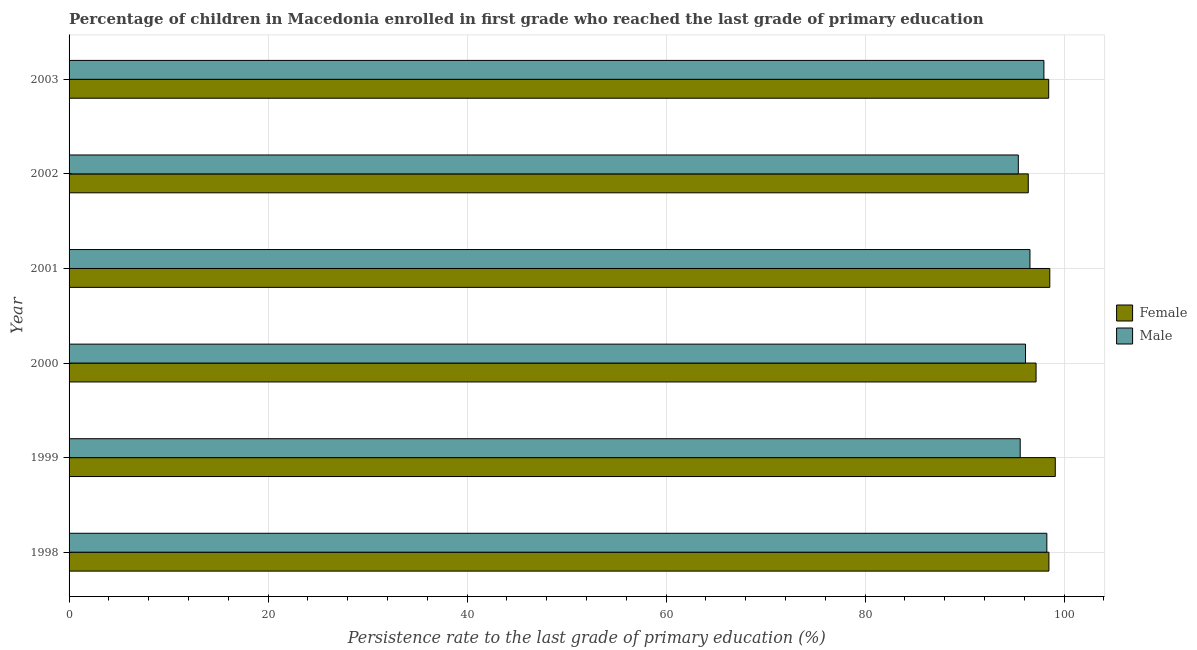Are the number of bars on each tick of the Y-axis equal?
Ensure brevity in your answer.  Yes. How many bars are there on the 3rd tick from the top?
Give a very brief answer. 2. How many bars are there on the 1st tick from the bottom?
Keep it short and to the point. 2. What is the persistence rate of female students in 2001?
Offer a terse response. 98.55. Across all years, what is the maximum persistence rate of male students?
Keep it short and to the point. 98.26. Across all years, what is the minimum persistence rate of male students?
Offer a terse response. 95.39. In which year was the persistence rate of female students maximum?
Your answer should be very brief. 1999. What is the total persistence rate of female students in the graph?
Ensure brevity in your answer.  588.14. What is the difference between the persistence rate of female students in 2000 and that in 2003?
Keep it short and to the point. -1.27. What is the difference between the persistence rate of male students in 1998 and the persistence rate of female students in 2001?
Ensure brevity in your answer.  -0.3. What is the average persistence rate of male students per year?
Make the answer very short. 96.64. In the year 2003, what is the difference between the persistence rate of female students and persistence rate of male students?
Offer a terse response. 0.48. In how many years, is the persistence rate of male students greater than 84 %?
Provide a succinct answer. 6. What is the ratio of the persistence rate of female students in 1998 to that in 2000?
Give a very brief answer. 1.01. Is the persistence rate of male students in 1999 less than that in 2002?
Offer a terse response. No. What is the difference between the highest and the second highest persistence rate of male students?
Keep it short and to the point. 0.29. What is the difference between the highest and the lowest persistence rate of male students?
Ensure brevity in your answer.  2.87. What does the 1st bar from the top in 2000 represents?
Your answer should be very brief. Male. What does the 2nd bar from the bottom in 1998 represents?
Your response must be concise. Male. Are all the bars in the graph horizontal?
Give a very brief answer. Yes. How many years are there in the graph?
Ensure brevity in your answer.  6. Does the graph contain grids?
Make the answer very short. Yes. How many legend labels are there?
Your answer should be very brief. 2. How are the legend labels stacked?
Keep it short and to the point. Vertical. What is the title of the graph?
Offer a terse response. Percentage of children in Macedonia enrolled in first grade who reached the last grade of primary education. What is the label or title of the X-axis?
Provide a short and direct response. Persistence rate to the last grade of primary education (%). What is the label or title of the Y-axis?
Provide a short and direct response. Year. What is the Persistence rate to the last grade of primary education (%) of Female in 1998?
Ensure brevity in your answer.  98.47. What is the Persistence rate to the last grade of primary education (%) in Male in 1998?
Keep it short and to the point. 98.26. What is the Persistence rate to the last grade of primary education (%) in Female in 1999?
Ensure brevity in your answer.  99.1. What is the Persistence rate to the last grade of primary education (%) of Male in 1999?
Offer a terse response. 95.58. What is the Persistence rate to the last grade of primary education (%) of Female in 2000?
Make the answer very short. 97.18. What is the Persistence rate to the last grade of primary education (%) of Male in 2000?
Offer a terse response. 96.11. What is the Persistence rate to the last grade of primary education (%) in Female in 2001?
Make the answer very short. 98.55. What is the Persistence rate to the last grade of primary education (%) of Male in 2001?
Ensure brevity in your answer.  96.56. What is the Persistence rate to the last grade of primary education (%) in Female in 2002?
Ensure brevity in your answer.  96.39. What is the Persistence rate to the last grade of primary education (%) of Male in 2002?
Offer a terse response. 95.39. What is the Persistence rate to the last grade of primary education (%) in Female in 2003?
Offer a terse response. 98.44. What is the Persistence rate to the last grade of primary education (%) in Male in 2003?
Ensure brevity in your answer.  97.96. Across all years, what is the maximum Persistence rate to the last grade of primary education (%) of Female?
Keep it short and to the point. 99.1. Across all years, what is the maximum Persistence rate to the last grade of primary education (%) of Male?
Your answer should be very brief. 98.26. Across all years, what is the minimum Persistence rate to the last grade of primary education (%) of Female?
Make the answer very short. 96.39. Across all years, what is the minimum Persistence rate to the last grade of primary education (%) of Male?
Offer a very short reply. 95.39. What is the total Persistence rate to the last grade of primary education (%) of Female in the graph?
Provide a succinct answer. 588.14. What is the total Persistence rate to the last grade of primary education (%) of Male in the graph?
Give a very brief answer. 579.87. What is the difference between the Persistence rate to the last grade of primary education (%) in Female in 1998 and that in 1999?
Keep it short and to the point. -0.64. What is the difference between the Persistence rate to the last grade of primary education (%) of Male in 1998 and that in 1999?
Keep it short and to the point. 2.68. What is the difference between the Persistence rate to the last grade of primary education (%) in Female in 1998 and that in 2000?
Ensure brevity in your answer.  1.29. What is the difference between the Persistence rate to the last grade of primary education (%) in Male in 1998 and that in 2000?
Ensure brevity in your answer.  2.14. What is the difference between the Persistence rate to the last grade of primary education (%) of Female in 1998 and that in 2001?
Your answer should be compact. -0.09. What is the difference between the Persistence rate to the last grade of primary education (%) in Male in 1998 and that in 2001?
Provide a short and direct response. 1.7. What is the difference between the Persistence rate to the last grade of primary education (%) in Female in 1998 and that in 2002?
Ensure brevity in your answer.  2.08. What is the difference between the Persistence rate to the last grade of primary education (%) of Male in 1998 and that in 2002?
Your answer should be compact. 2.87. What is the difference between the Persistence rate to the last grade of primary education (%) of Female in 1998 and that in 2003?
Your response must be concise. 0.02. What is the difference between the Persistence rate to the last grade of primary education (%) in Male in 1998 and that in 2003?
Your response must be concise. 0.3. What is the difference between the Persistence rate to the last grade of primary education (%) in Female in 1999 and that in 2000?
Give a very brief answer. 1.93. What is the difference between the Persistence rate to the last grade of primary education (%) of Male in 1999 and that in 2000?
Provide a short and direct response. -0.53. What is the difference between the Persistence rate to the last grade of primary education (%) of Female in 1999 and that in 2001?
Offer a very short reply. 0.55. What is the difference between the Persistence rate to the last grade of primary education (%) of Male in 1999 and that in 2001?
Ensure brevity in your answer.  -0.98. What is the difference between the Persistence rate to the last grade of primary education (%) in Female in 1999 and that in 2002?
Give a very brief answer. 2.71. What is the difference between the Persistence rate to the last grade of primary education (%) of Male in 1999 and that in 2002?
Your response must be concise. 0.19. What is the difference between the Persistence rate to the last grade of primary education (%) in Female in 1999 and that in 2003?
Provide a succinct answer. 0.66. What is the difference between the Persistence rate to the last grade of primary education (%) of Male in 1999 and that in 2003?
Give a very brief answer. -2.38. What is the difference between the Persistence rate to the last grade of primary education (%) in Female in 2000 and that in 2001?
Offer a terse response. -1.38. What is the difference between the Persistence rate to the last grade of primary education (%) of Male in 2000 and that in 2001?
Your answer should be very brief. -0.45. What is the difference between the Persistence rate to the last grade of primary education (%) in Female in 2000 and that in 2002?
Keep it short and to the point. 0.79. What is the difference between the Persistence rate to the last grade of primary education (%) of Male in 2000 and that in 2002?
Your response must be concise. 0.72. What is the difference between the Persistence rate to the last grade of primary education (%) in Female in 2000 and that in 2003?
Make the answer very short. -1.27. What is the difference between the Persistence rate to the last grade of primary education (%) of Male in 2000 and that in 2003?
Make the answer very short. -1.85. What is the difference between the Persistence rate to the last grade of primary education (%) of Female in 2001 and that in 2002?
Offer a terse response. 2.16. What is the difference between the Persistence rate to the last grade of primary education (%) of Male in 2001 and that in 2002?
Your response must be concise. 1.17. What is the difference between the Persistence rate to the last grade of primary education (%) of Female in 2001 and that in 2003?
Keep it short and to the point. 0.11. What is the difference between the Persistence rate to the last grade of primary education (%) in Male in 2001 and that in 2003?
Your answer should be compact. -1.4. What is the difference between the Persistence rate to the last grade of primary education (%) in Female in 2002 and that in 2003?
Offer a very short reply. -2.05. What is the difference between the Persistence rate to the last grade of primary education (%) in Male in 2002 and that in 2003?
Your answer should be compact. -2.57. What is the difference between the Persistence rate to the last grade of primary education (%) of Female in 1998 and the Persistence rate to the last grade of primary education (%) of Male in 1999?
Make the answer very short. 2.89. What is the difference between the Persistence rate to the last grade of primary education (%) in Female in 1998 and the Persistence rate to the last grade of primary education (%) in Male in 2000?
Provide a succinct answer. 2.35. What is the difference between the Persistence rate to the last grade of primary education (%) of Female in 1998 and the Persistence rate to the last grade of primary education (%) of Male in 2001?
Keep it short and to the point. 1.9. What is the difference between the Persistence rate to the last grade of primary education (%) in Female in 1998 and the Persistence rate to the last grade of primary education (%) in Male in 2002?
Make the answer very short. 3.08. What is the difference between the Persistence rate to the last grade of primary education (%) of Female in 1998 and the Persistence rate to the last grade of primary education (%) of Male in 2003?
Provide a succinct answer. 0.5. What is the difference between the Persistence rate to the last grade of primary education (%) of Female in 1999 and the Persistence rate to the last grade of primary education (%) of Male in 2000?
Make the answer very short. 2.99. What is the difference between the Persistence rate to the last grade of primary education (%) of Female in 1999 and the Persistence rate to the last grade of primary education (%) of Male in 2001?
Offer a very short reply. 2.54. What is the difference between the Persistence rate to the last grade of primary education (%) of Female in 1999 and the Persistence rate to the last grade of primary education (%) of Male in 2002?
Ensure brevity in your answer.  3.71. What is the difference between the Persistence rate to the last grade of primary education (%) of Female in 1999 and the Persistence rate to the last grade of primary education (%) of Male in 2003?
Keep it short and to the point. 1.14. What is the difference between the Persistence rate to the last grade of primary education (%) in Female in 2000 and the Persistence rate to the last grade of primary education (%) in Male in 2001?
Offer a very short reply. 0.61. What is the difference between the Persistence rate to the last grade of primary education (%) in Female in 2000 and the Persistence rate to the last grade of primary education (%) in Male in 2002?
Provide a short and direct response. 1.78. What is the difference between the Persistence rate to the last grade of primary education (%) of Female in 2000 and the Persistence rate to the last grade of primary education (%) of Male in 2003?
Ensure brevity in your answer.  -0.79. What is the difference between the Persistence rate to the last grade of primary education (%) in Female in 2001 and the Persistence rate to the last grade of primary education (%) in Male in 2002?
Provide a succinct answer. 3.16. What is the difference between the Persistence rate to the last grade of primary education (%) of Female in 2001 and the Persistence rate to the last grade of primary education (%) of Male in 2003?
Your response must be concise. 0.59. What is the difference between the Persistence rate to the last grade of primary education (%) in Female in 2002 and the Persistence rate to the last grade of primary education (%) in Male in 2003?
Offer a very short reply. -1.57. What is the average Persistence rate to the last grade of primary education (%) of Female per year?
Your answer should be compact. 98.02. What is the average Persistence rate to the last grade of primary education (%) of Male per year?
Keep it short and to the point. 96.64. In the year 1998, what is the difference between the Persistence rate to the last grade of primary education (%) in Female and Persistence rate to the last grade of primary education (%) in Male?
Keep it short and to the point. 0.21. In the year 1999, what is the difference between the Persistence rate to the last grade of primary education (%) of Female and Persistence rate to the last grade of primary education (%) of Male?
Keep it short and to the point. 3.52. In the year 2000, what is the difference between the Persistence rate to the last grade of primary education (%) in Female and Persistence rate to the last grade of primary education (%) in Male?
Provide a short and direct response. 1.06. In the year 2001, what is the difference between the Persistence rate to the last grade of primary education (%) of Female and Persistence rate to the last grade of primary education (%) of Male?
Keep it short and to the point. 1.99. In the year 2003, what is the difference between the Persistence rate to the last grade of primary education (%) of Female and Persistence rate to the last grade of primary education (%) of Male?
Your answer should be compact. 0.48. What is the ratio of the Persistence rate to the last grade of primary education (%) of Female in 1998 to that in 1999?
Offer a very short reply. 0.99. What is the ratio of the Persistence rate to the last grade of primary education (%) in Male in 1998 to that in 1999?
Your answer should be compact. 1.03. What is the ratio of the Persistence rate to the last grade of primary education (%) of Female in 1998 to that in 2000?
Offer a terse response. 1.01. What is the ratio of the Persistence rate to the last grade of primary education (%) in Male in 1998 to that in 2000?
Make the answer very short. 1.02. What is the ratio of the Persistence rate to the last grade of primary education (%) in Male in 1998 to that in 2001?
Offer a terse response. 1.02. What is the ratio of the Persistence rate to the last grade of primary education (%) of Female in 1998 to that in 2002?
Give a very brief answer. 1.02. What is the ratio of the Persistence rate to the last grade of primary education (%) of Male in 1998 to that in 2002?
Ensure brevity in your answer.  1.03. What is the ratio of the Persistence rate to the last grade of primary education (%) of Female in 1998 to that in 2003?
Your answer should be compact. 1. What is the ratio of the Persistence rate to the last grade of primary education (%) of Male in 1998 to that in 2003?
Your response must be concise. 1. What is the ratio of the Persistence rate to the last grade of primary education (%) in Female in 1999 to that in 2000?
Ensure brevity in your answer.  1.02. What is the ratio of the Persistence rate to the last grade of primary education (%) of Female in 1999 to that in 2001?
Provide a succinct answer. 1.01. What is the ratio of the Persistence rate to the last grade of primary education (%) in Male in 1999 to that in 2001?
Your answer should be very brief. 0.99. What is the ratio of the Persistence rate to the last grade of primary education (%) of Female in 1999 to that in 2002?
Your answer should be very brief. 1.03. What is the ratio of the Persistence rate to the last grade of primary education (%) of Male in 1999 to that in 2003?
Your answer should be very brief. 0.98. What is the ratio of the Persistence rate to the last grade of primary education (%) in Female in 2000 to that in 2001?
Keep it short and to the point. 0.99. What is the ratio of the Persistence rate to the last grade of primary education (%) of Male in 2000 to that in 2001?
Make the answer very short. 1. What is the ratio of the Persistence rate to the last grade of primary education (%) of Female in 2000 to that in 2002?
Ensure brevity in your answer.  1.01. What is the ratio of the Persistence rate to the last grade of primary education (%) of Male in 2000 to that in 2002?
Your answer should be very brief. 1.01. What is the ratio of the Persistence rate to the last grade of primary education (%) of Female in 2000 to that in 2003?
Provide a succinct answer. 0.99. What is the ratio of the Persistence rate to the last grade of primary education (%) in Male in 2000 to that in 2003?
Your answer should be compact. 0.98. What is the ratio of the Persistence rate to the last grade of primary education (%) of Female in 2001 to that in 2002?
Provide a succinct answer. 1.02. What is the ratio of the Persistence rate to the last grade of primary education (%) in Male in 2001 to that in 2002?
Make the answer very short. 1.01. What is the ratio of the Persistence rate to the last grade of primary education (%) of Male in 2001 to that in 2003?
Provide a short and direct response. 0.99. What is the ratio of the Persistence rate to the last grade of primary education (%) in Female in 2002 to that in 2003?
Provide a succinct answer. 0.98. What is the ratio of the Persistence rate to the last grade of primary education (%) of Male in 2002 to that in 2003?
Give a very brief answer. 0.97. What is the difference between the highest and the second highest Persistence rate to the last grade of primary education (%) of Female?
Make the answer very short. 0.55. What is the difference between the highest and the second highest Persistence rate to the last grade of primary education (%) of Male?
Offer a very short reply. 0.3. What is the difference between the highest and the lowest Persistence rate to the last grade of primary education (%) in Female?
Provide a succinct answer. 2.71. What is the difference between the highest and the lowest Persistence rate to the last grade of primary education (%) of Male?
Give a very brief answer. 2.87. 